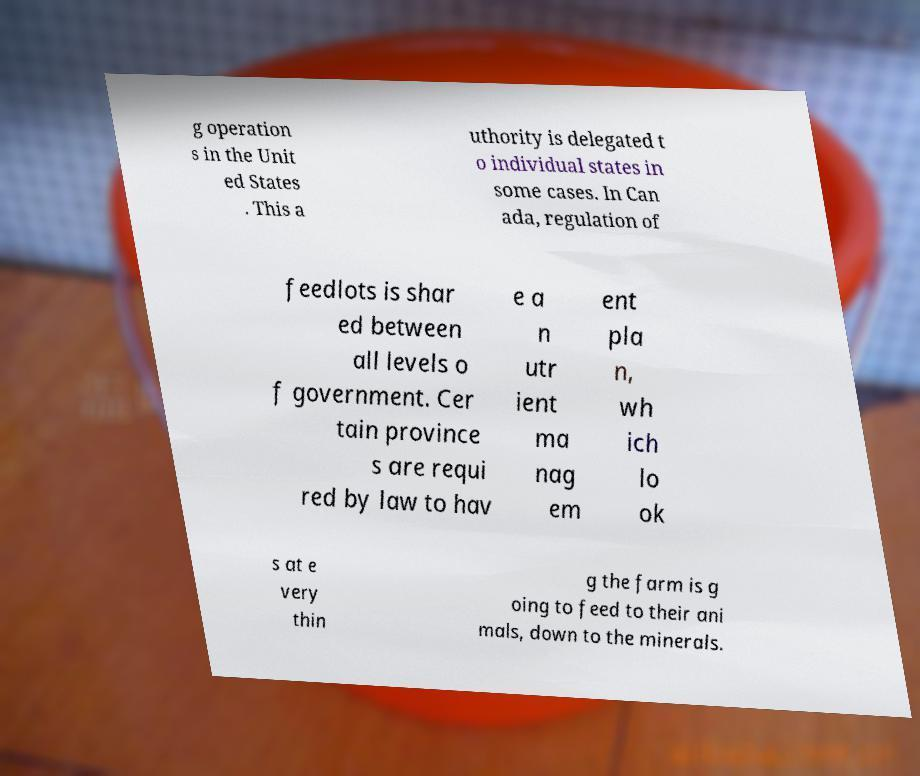Can you accurately transcribe the text from the provided image for me? g operation s in the Unit ed States . This a uthority is delegated t o individual states in some cases. In Can ada, regulation of feedlots is shar ed between all levels o f government. Cer tain province s are requi red by law to hav e a n utr ient ma nag em ent pla n, wh ich lo ok s at e very thin g the farm is g oing to feed to their ani mals, down to the minerals. 